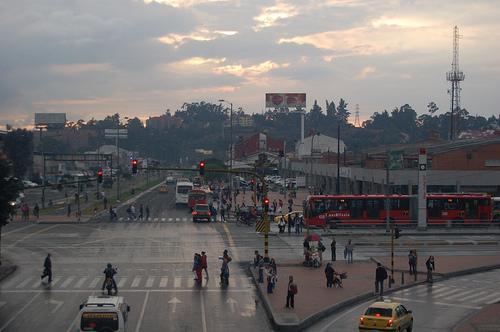How many cows can you see?
Give a very brief answer. 0. 